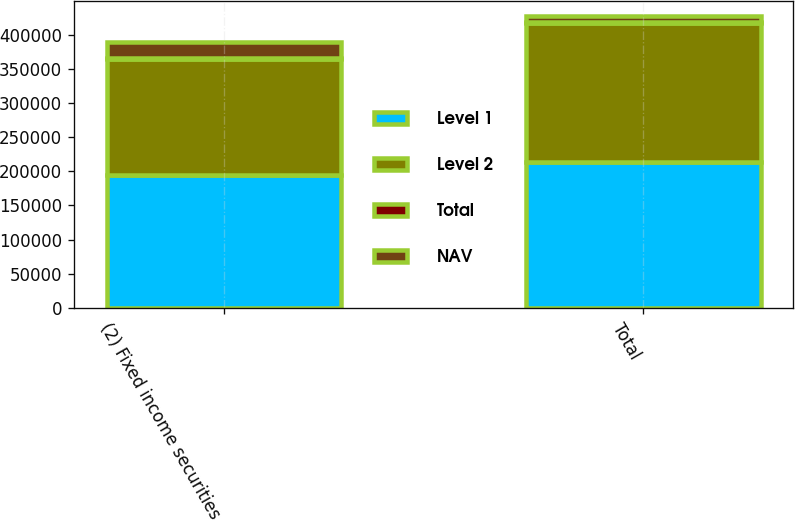Convert chart to OTSL. <chart><loc_0><loc_0><loc_500><loc_500><stacked_bar_chart><ecel><fcel>(2) Fixed income securities<fcel>Total<nl><fcel>Level 1<fcel>194739<fcel>213689<nl><fcel>Level 2<fcel>170249<fcel>203285<nl><fcel>Total<fcel>474<fcel>1626<nl><fcel>NAV<fcel>24490<fcel>8778<nl></chart> 